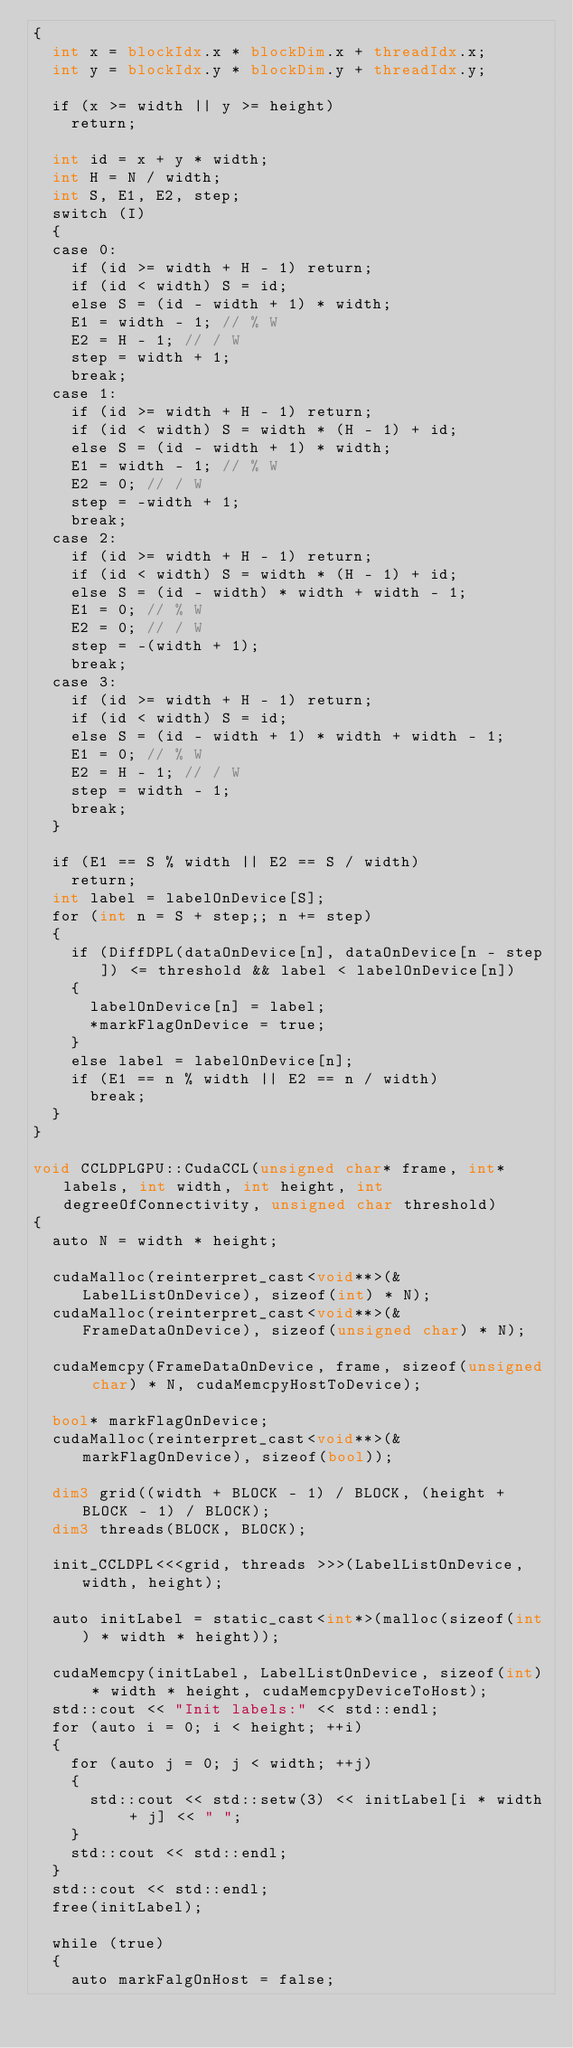<code> <loc_0><loc_0><loc_500><loc_500><_Cuda_>{
	int x = blockIdx.x * blockDim.x + threadIdx.x;
	int y = blockIdx.y * blockDim.y + threadIdx.y;

	if (x >= width || y >= height)
		return;

	int id = x + y * width;
	int H = N / width;
	int S, E1, E2, step;
	switch (I)
	{
	case 0:
		if (id >= width + H - 1) return;
		if (id < width) S = id;
		else S = (id - width + 1) * width;
		E1 = width - 1; // % W
		E2 = H - 1; // / W
		step = width + 1;
		break;
	case 1:
		if (id >= width + H - 1) return;
		if (id < width) S = width * (H - 1) + id;
		else S = (id - width + 1) * width;
		E1 = width - 1; // % W
		E2 = 0; // / W
		step = -width + 1;
		break;
	case 2:
		if (id >= width + H - 1) return;
		if (id < width) S = width * (H - 1) + id;
		else S = (id - width) * width + width - 1;
		E1 = 0; // % W
		E2 = 0; // / W
		step = -(width + 1);
		break;
	case 3:
		if (id >= width + H - 1) return;
		if (id < width) S = id;
		else S = (id - width + 1) * width + width - 1;
		E1 = 0; // % W
		E2 = H - 1; // / W
		step = width - 1;
		break;
	}

	if (E1 == S % width || E2 == S / width)
		return;
	int label = labelOnDevice[S];
	for (int n = S + step;; n += step)
	{
		if (DiffDPL(dataOnDevice[n], dataOnDevice[n - step]) <= threshold && label < labelOnDevice[n])
		{
			labelOnDevice[n] = label;
			*markFlagOnDevice = true;
		}
		else label = labelOnDevice[n];
		if (E1 == n % width || E2 == n / width)
			break;
	}
}

void CCLDPLGPU::CudaCCL(unsigned char* frame, int* labels, int width, int height, int degreeOfConnectivity, unsigned char threshold)
{
	auto N = width * height;

	cudaMalloc(reinterpret_cast<void**>(&LabelListOnDevice), sizeof(int) * N);
	cudaMalloc(reinterpret_cast<void**>(&FrameDataOnDevice), sizeof(unsigned char) * N);

	cudaMemcpy(FrameDataOnDevice, frame, sizeof(unsigned char) * N, cudaMemcpyHostToDevice);

	bool* markFlagOnDevice;
	cudaMalloc(reinterpret_cast<void**>(&markFlagOnDevice), sizeof(bool));

	dim3 grid((width + BLOCK - 1) / BLOCK, (height + BLOCK - 1) / BLOCK);
	dim3 threads(BLOCK, BLOCK);

	init_CCLDPL<<<grid, threads >>>(LabelListOnDevice, width, height);

	auto initLabel = static_cast<int*>(malloc(sizeof(int) * width * height));

	cudaMemcpy(initLabel, LabelListOnDevice, sizeof(int) * width * height, cudaMemcpyDeviceToHost);
	std::cout << "Init labels:" << std::endl;
	for (auto i = 0; i < height; ++i)
	{
		for (auto j = 0; j < width; ++j)
		{
			std::cout << std::setw(3) << initLabel[i * width + j] << " ";
		}
		std::cout << std::endl;
	}
	std::cout << std::endl;
	free(initLabel);

	while (true)
	{
		auto markFalgOnHost = false;</code> 